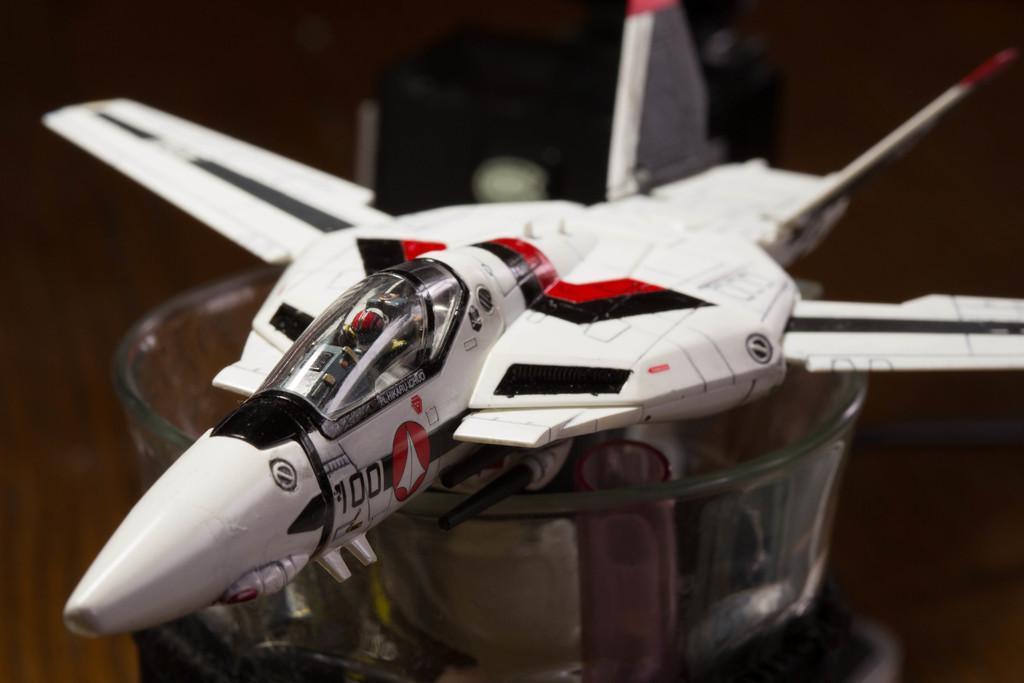Describe this image in one or two sentences. In this image in the center there is one toy airplane, and at the bottom there is bowl. And at the bottom it looks like a wooden table, in the background there is some object. 